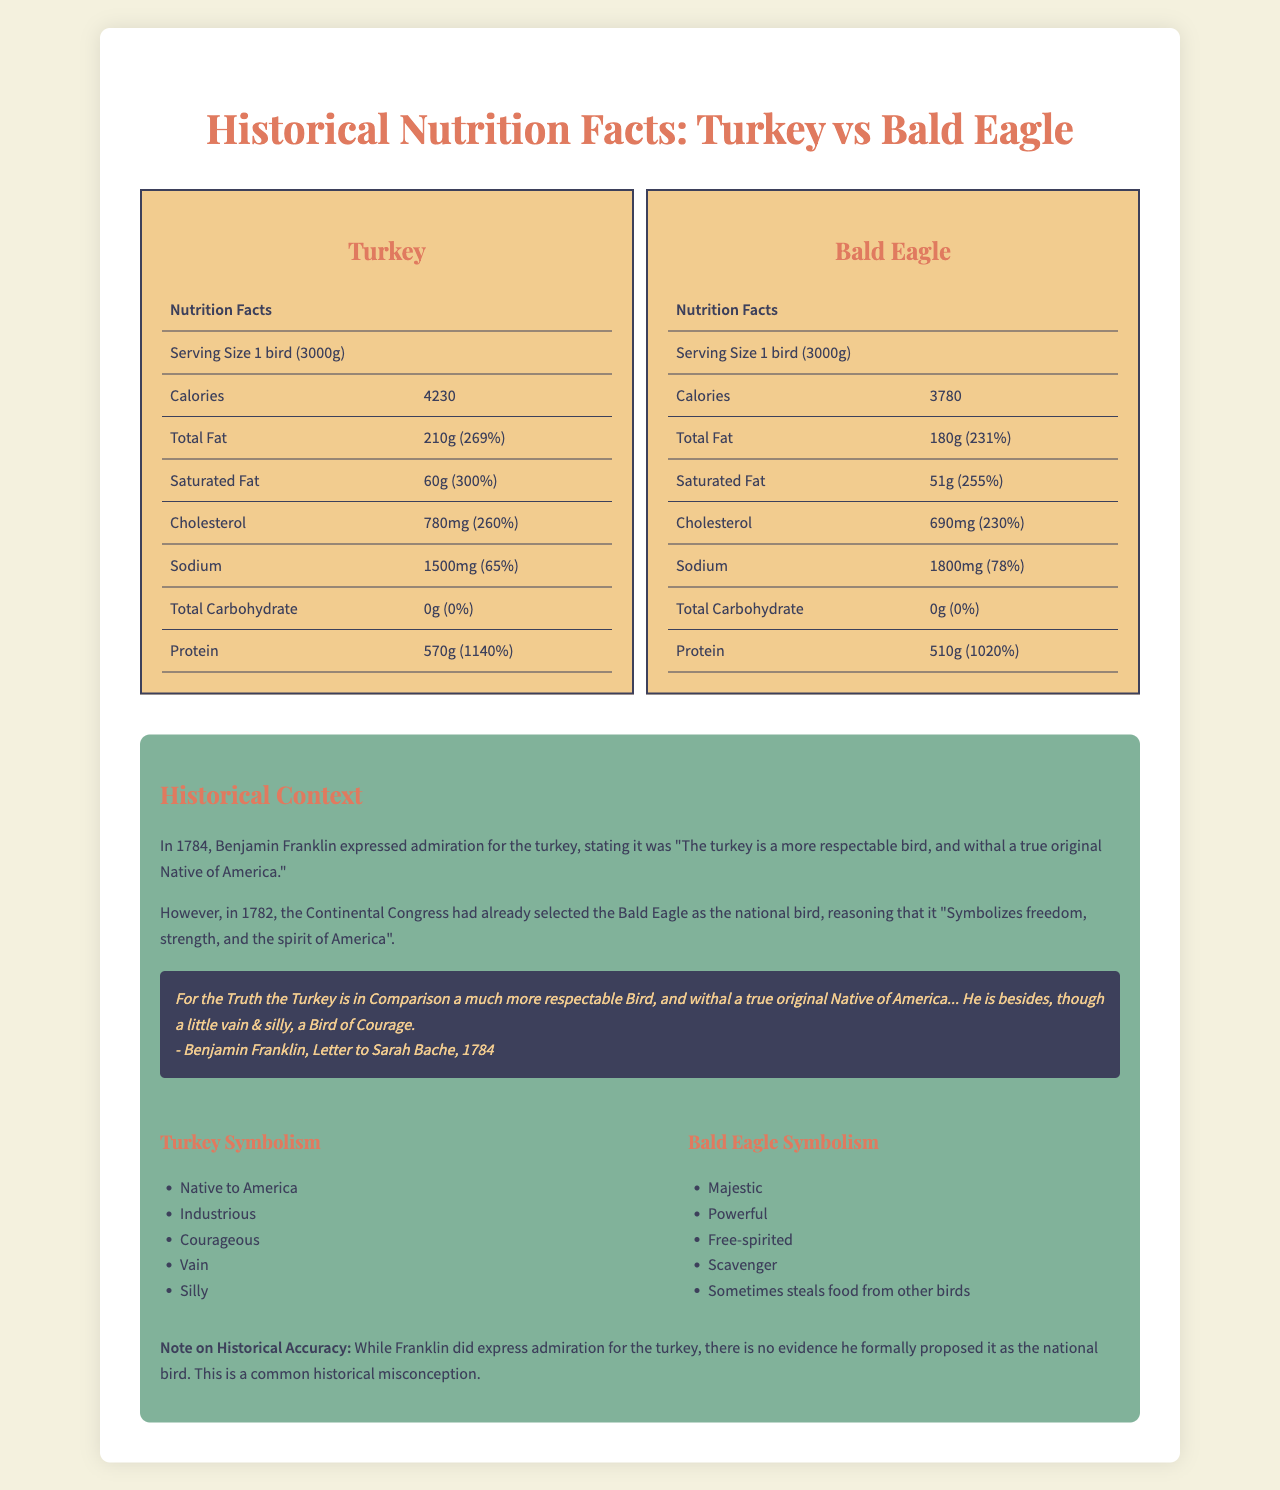what is the calorie count for a serving of turkey? The document lists the calorie count per serving for the turkey as 4230.
Answer: 4230 what is the cholesterol content in a serving of bald eagle? The document specifies that the cholesterol content in a serving of bald eagle is 690mg.
Answer: 690mg how much protein is in a serving of turkey? The protein amount for a serving of turkey is listed as 570g in the document.
Answer: 570g what year did the Continental Congress select the bald eagle as the national bird? According to the historical context section, the Continental Congress selected the bald eagle in the year 1782.
Answer: 1782 who proposed the turkey as a national bird and in what year? The document states that Benjamin Franklin proposed the turkey as a national bird in 1784.
Answer: Benjamin Franklin, 1784 which bird has a higher percentage of daily value for iron? A. Turkey B. Bald Eagle The bald eagle has an iron percentage of 50%, compared to the turkey's 45%.
Answer: B. Bald Eagle which vitamin does the bald eagle have a higher percentage of than the turkey? A. Vitamin A B. Vitamin C C. Vitamin B6 D. Vitamin B12 The bald eagle has 200% of vitamin B12, while the turkey has 180%.
Answer: D. Vitamin B12 is there any carbohydrate content in either bird? The document indicates that both the turkey and the bald eagle have 0g of total carbohydrate.
Answer: No what are some positive traits associated with the turkey according to Benjamin Franklin? In the historical context section, the turkey is described as Native to America, Industrious, and Courageous.
Answer: Native to America, Industrious, Courageous what is the main idea of this document? The document includes a detailed comparison of the nutritional facts for turkey and bald eagle and provides historical context regarding their symbolism and the selection process for the national bird.
Answer: Comparing the nutritional facts of turkey and bald eagle, along with historical context on American symbolism and the selection of the national bird. how many gallons of water should be consumed to offset the high sodium content in a serving of bald eagle? The document does not provide information on the amount of water needed to offset the sodium content.
Answer: Not enough information 